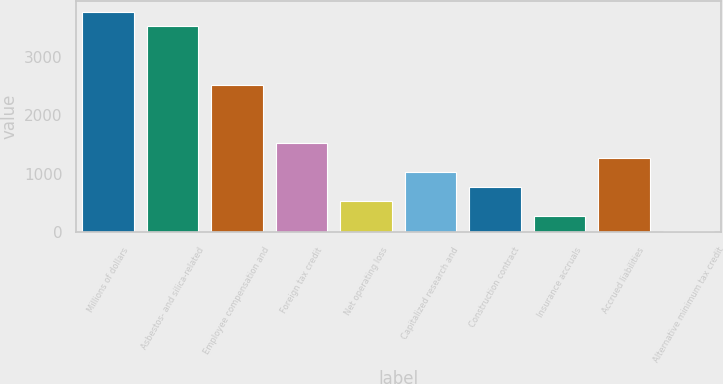Convert chart to OTSL. <chart><loc_0><loc_0><loc_500><loc_500><bar_chart><fcel>Millions of dollars<fcel>Asbestos- and silica-related<fcel>Employee compensation and<fcel>Foreign tax credit<fcel>Net operating loss<fcel>Capitalized research and<fcel>Construction contract<fcel>Insurance accruals<fcel>Accrued liabilities<fcel>Alternative minimum tax credit<nl><fcel>3774<fcel>3524.4<fcel>2526<fcel>1527.6<fcel>529.2<fcel>1028.4<fcel>778.8<fcel>279.6<fcel>1278<fcel>30<nl></chart> 